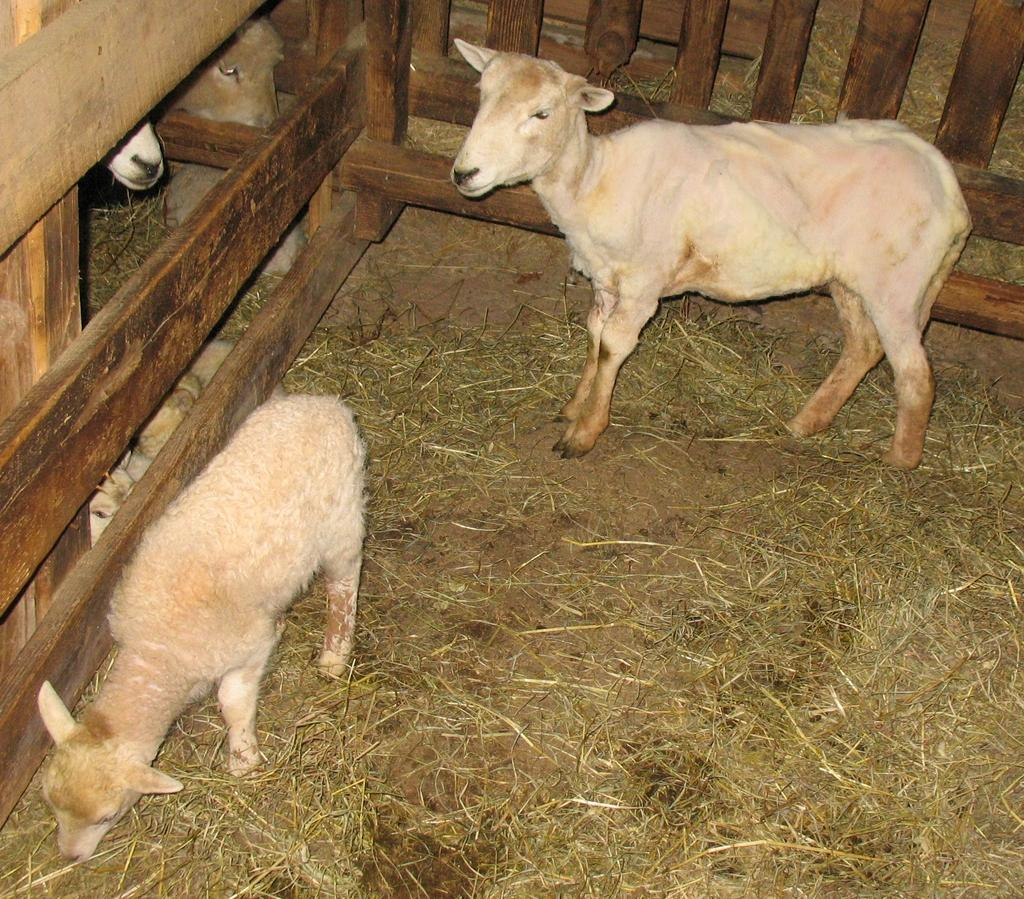What types of animals can be seen in the image? There are two animals visible in the image. What is the ground surface like in the image? There is grass on the floor in the image. What is located beside the animals? There is a fence beside the animals. Can you describe the area beyond the fence? There are more animals visible behind the fence. How loud is the card being played in the image? There is no card being played in the image; it features two animals and a fence. 